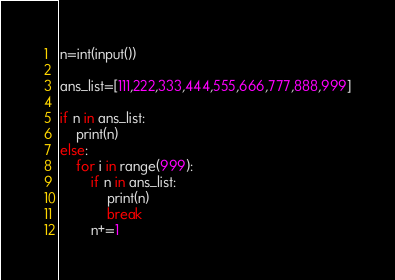Convert code to text. <code><loc_0><loc_0><loc_500><loc_500><_Python_>n=int(input())

ans_list=[111,222,333,444,555,666,777,888,999]

if n in ans_list:
    print(n)
else:
    for i in range(999):
        if n in ans_list:
            print(n)
            break
        n+=1</code> 